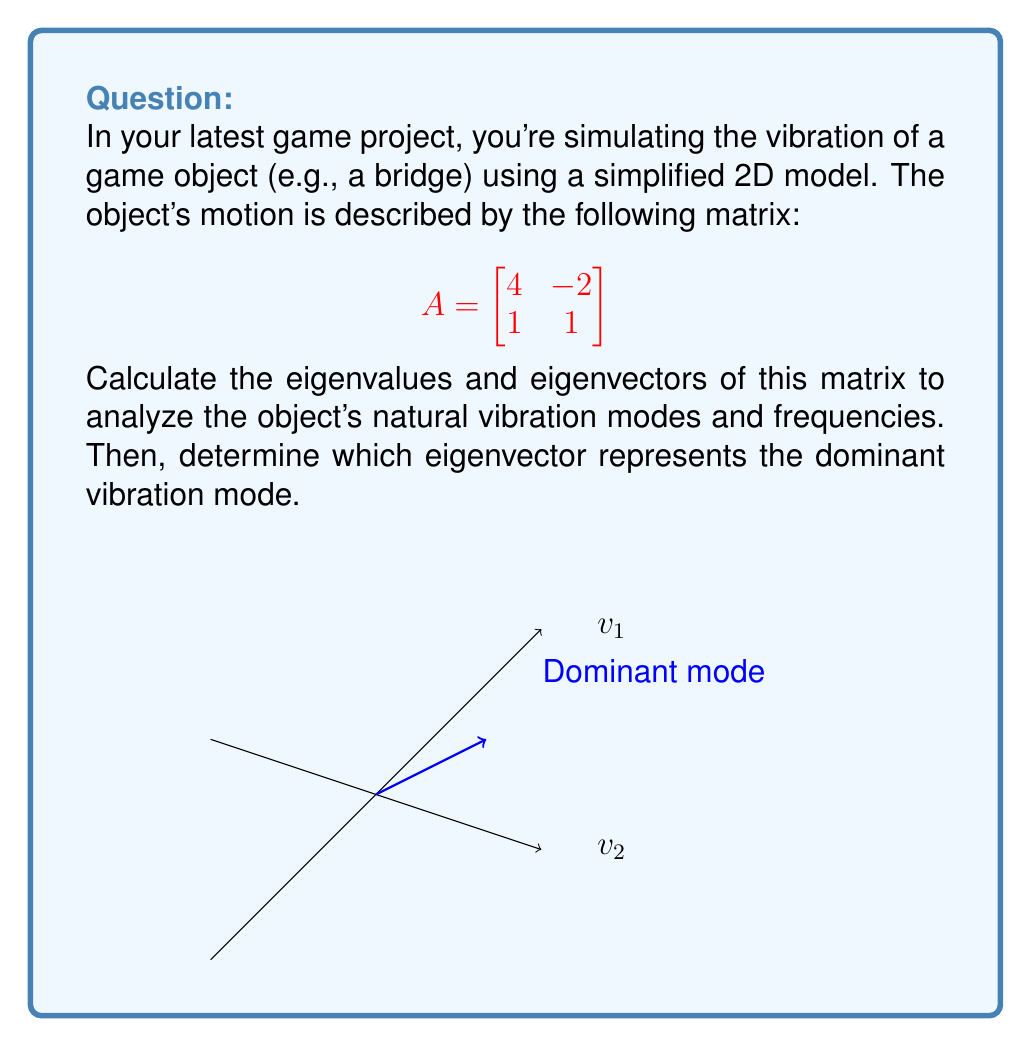What is the answer to this math problem? Let's solve this step-by-step:

1) To find eigenvalues, we solve the characteristic equation:
   $$det(A - \lambda I) = 0$$
   
   $$\begin{vmatrix}
   4-\lambda & -2 \\
   1 & 1-\lambda
   \end{vmatrix} = 0$$

2) Expanding the determinant:
   $$(4-\lambda)(1-\lambda) - (-2)(1) = 0$$
   $$4 - 4\lambda + \lambda^2 - \lambda + 2 = 0$$
   $$\lambda^2 - 5\lambda + 6 = 0$$

3) Solving this quadratic equation:
   $$(\lambda - 3)(\lambda - 2) = 0$$
   $$\lambda_1 = 3, \lambda_2 = 2$$

4) For each eigenvalue, we find the corresponding eigenvector by solving $(A - \lambda I)v = 0$:

   For $\lambda_1 = 3$:
   $$\begin{bmatrix}
   1 & -2 \\
   1 & -2
   \end{bmatrix}\begin{bmatrix}
   v_1 \\
   v_2
   \end{bmatrix} = \begin{bmatrix}
   0 \\
   0
   \end{bmatrix}$$
   
   This gives us $v_1 = 2v_2$, so $v_1 = \begin{bmatrix} 2 \\ 1 \end{bmatrix}$

   For $\lambda_2 = 2$:
   $$\begin{bmatrix}
   2 & -2 \\
   1 & -1
   \end{bmatrix}\begin{bmatrix}
   v_1 \\
   v_2
   \end{bmatrix} = \begin{bmatrix}
   0 \\
   0
   \end{bmatrix}$$
   
   This gives us $v_1 = v_2$, so $v_2 = \begin{bmatrix} 1 \\ 1 \end{bmatrix}$

5) The dominant vibration mode corresponds to the eigenvector with the largest eigenvalue. Since $\lambda_1 > \lambda_2$, the dominant mode is $v_1 = \begin{bmatrix} 2 \\ 1 \end{bmatrix}$.
Answer: Eigenvalues: $\lambda_1 = 3$, $\lambda_2 = 2$
Eigenvectors: $v_1 = \begin{bmatrix} 2 \\ 1 \end{bmatrix}$, $v_2 = \begin{bmatrix} 1 \\ 1 \end{bmatrix}$
Dominant mode: $v_1 = \begin{bmatrix} 2 \\ 1 \end{bmatrix}$ 